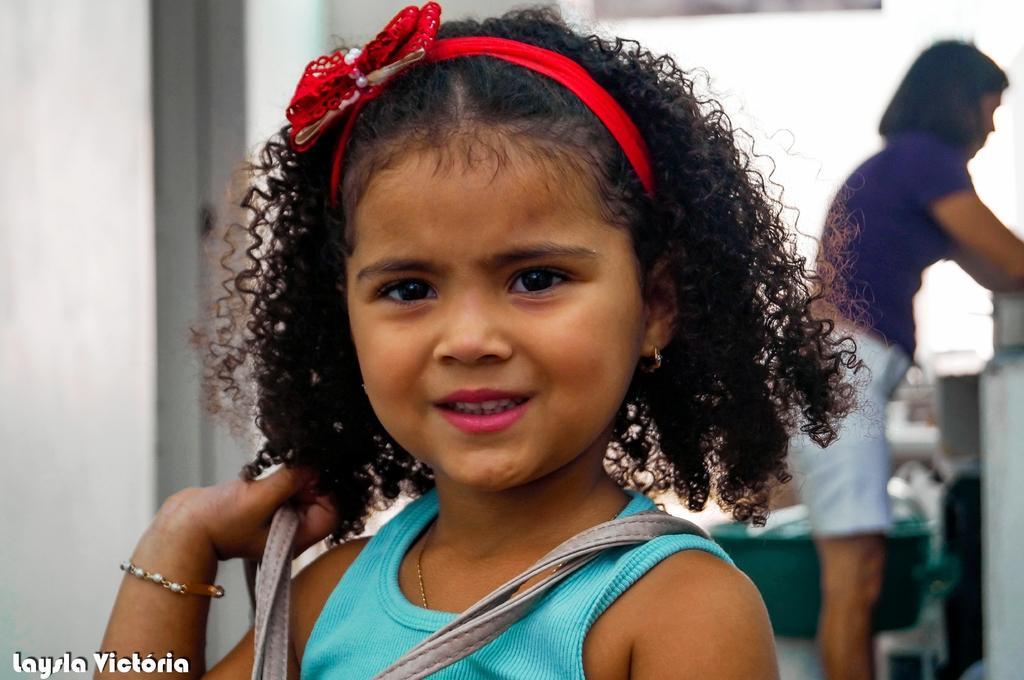In one or two sentences, can you explain what this image depicts? In this image, we can see a girl is smiling and wearing hairband. She is holding some object. Background there is a blur view. Here a woman is standing. we can see so many things and objects here. Left side bottom of the image, we can see some text. Here there is a wall. 